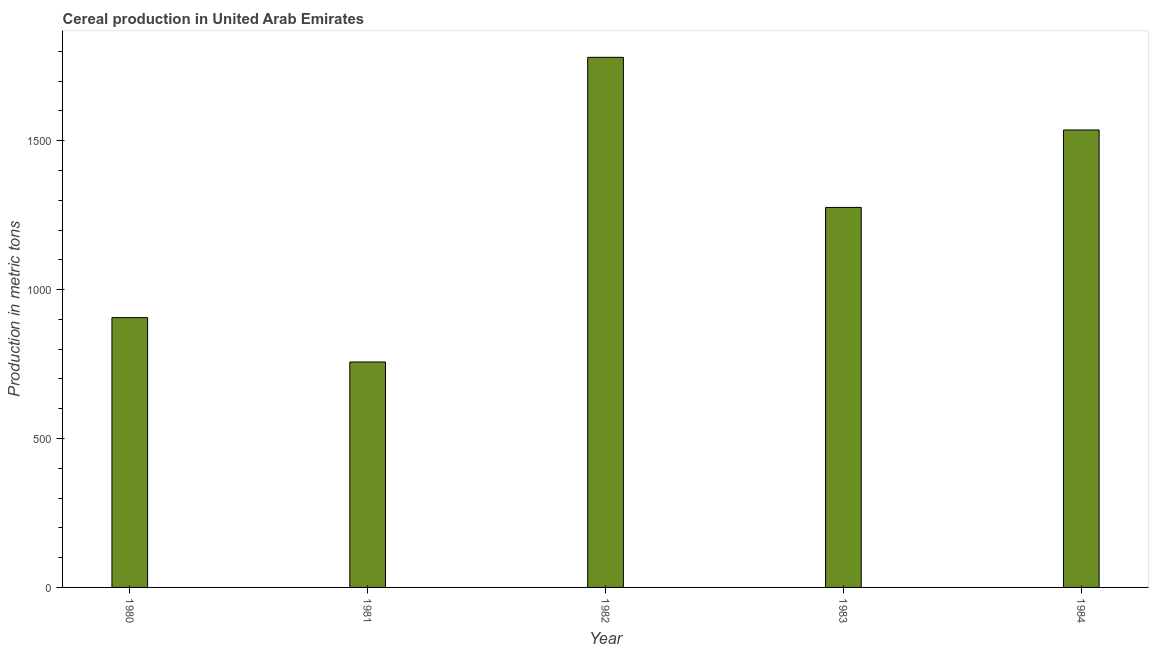Does the graph contain any zero values?
Provide a succinct answer. No. Does the graph contain grids?
Your response must be concise. No. What is the title of the graph?
Offer a very short reply. Cereal production in United Arab Emirates. What is the label or title of the Y-axis?
Offer a terse response. Production in metric tons. What is the cereal production in 1980?
Your response must be concise. 906. Across all years, what is the maximum cereal production?
Provide a succinct answer. 1780. Across all years, what is the minimum cereal production?
Offer a terse response. 757. In which year was the cereal production maximum?
Your answer should be compact. 1982. In which year was the cereal production minimum?
Ensure brevity in your answer.  1981. What is the sum of the cereal production?
Your answer should be compact. 6255. What is the difference between the cereal production in 1980 and 1983?
Provide a succinct answer. -370. What is the average cereal production per year?
Keep it short and to the point. 1251. What is the median cereal production?
Make the answer very short. 1276. In how many years, is the cereal production greater than 1600 metric tons?
Your response must be concise. 1. Do a majority of the years between 1982 and 1980 (inclusive) have cereal production greater than 1200 metric tons?
Give a very brief answer. Yes. What is the ratio of the cereal production in 1981 to that in 1984?
Offer a terse response. 0.49. Is the cereal production in 1981 less than that in 1982?
Your answer should be compact. Yes. Is the difference between the cereal production in 1980 and 1983 greater than the difference between any two years?
Provide a succinct answer. No. What is the difference between the highest and the second highest cereal production?
Your answer should be very brief. 244. Is the sum of the cereal production in 1983 and 1984 greater than the maximum cereal production across all years?
Your answer should be compact. Yes. What is the difference between the highest and the lowest cereal production?
Your answer should be very brief. 1023. How many years are there in the graph?
Provide a succinct answer. 5. What is the difference between two consecutive major ticks on the Y-axis?
Offer a very short reply. 500. What is the Production in metric tons in 1980?
Your response must be concise. 906. What is the Production in metric tons in 1981?
Keep it short and to the point. 757. What is the Production in metric tons in 1982?
Ensure brevity in your answer.  1780. What is the Production in metric tons in 1983?
Offer a terse response. 1276. What is the Production in metric tons of 1984?
Provide a short and direct response. 1536. What is the difference between the Production in metric tons in 1980 and 1981?
Offer a terse response. 149. What is the difference between the Production in metric tons in 1980 and 1982?
Provide a short and direct response. -874. What is the difference between the Production in metric tons in 1980 and 1983?
Make the answer very short. -370. What is the difference between the Production in metric tons in 1980 and 1984?
Give a very brief answer. -630. What is the difference between the Production in metric tons in 1981 and 1982?
Your answer should be compact. -1023. What is the difference between the Production in metric tons in 1981 and 1983?
Your answer should be compact. -519. What is the difference between the Production in metric tons in 1981 and 1984?
Ensure brevity in your answer.  -779. What is the difference between the Production in metric tons in 1982 and 1983?
Your answer should be compact. 504. What is the difference between the Production in metric tons in 1982 and 1984?
Provide a short and direct response. 244. What is the difference between the Production in metric tons in 1983 and 1984?
Your response must be concise. -260. What is the ratio of the Production in metric tons in 1980 to that in 1981?
Your answer should be compact. 1.2. What is the ratio of the Production in metric tons in 1980 to that in 1982?
Ensure brevity in your answer.  0.51. What is the ratio of the Production in metric tons in 1980 to that in 1983?
Ensure brevity in your answer.  0.71. What is the ratio of the Production in metric tons in 1980 to that in 1984?
Keep it short and to the point. 0.59. What is the ratio of the Production in metric tons in 1981 to that in 1982?
Provide a short and direct response. 0.42. What is the ratio of the Production in metric tons in 1981 to that in 1983?
Offer a very short reply. 0.59. What is the ratio of the Production in metric tons in 1981 to that in 1984?
Provide a short and direct response. 0.49. What is the ratio of the Production in metric tons in 1982 to that in 1983?
Your response must be concise. 1.4. What is the ratio of the Production in metric tons in 1982 to that in 1984?
Offer a very short reply. 1.16. What is the ratio of the Production in metric tons in 1983 to that in 1984?
Ensure brevity in your answer.  0.83. 